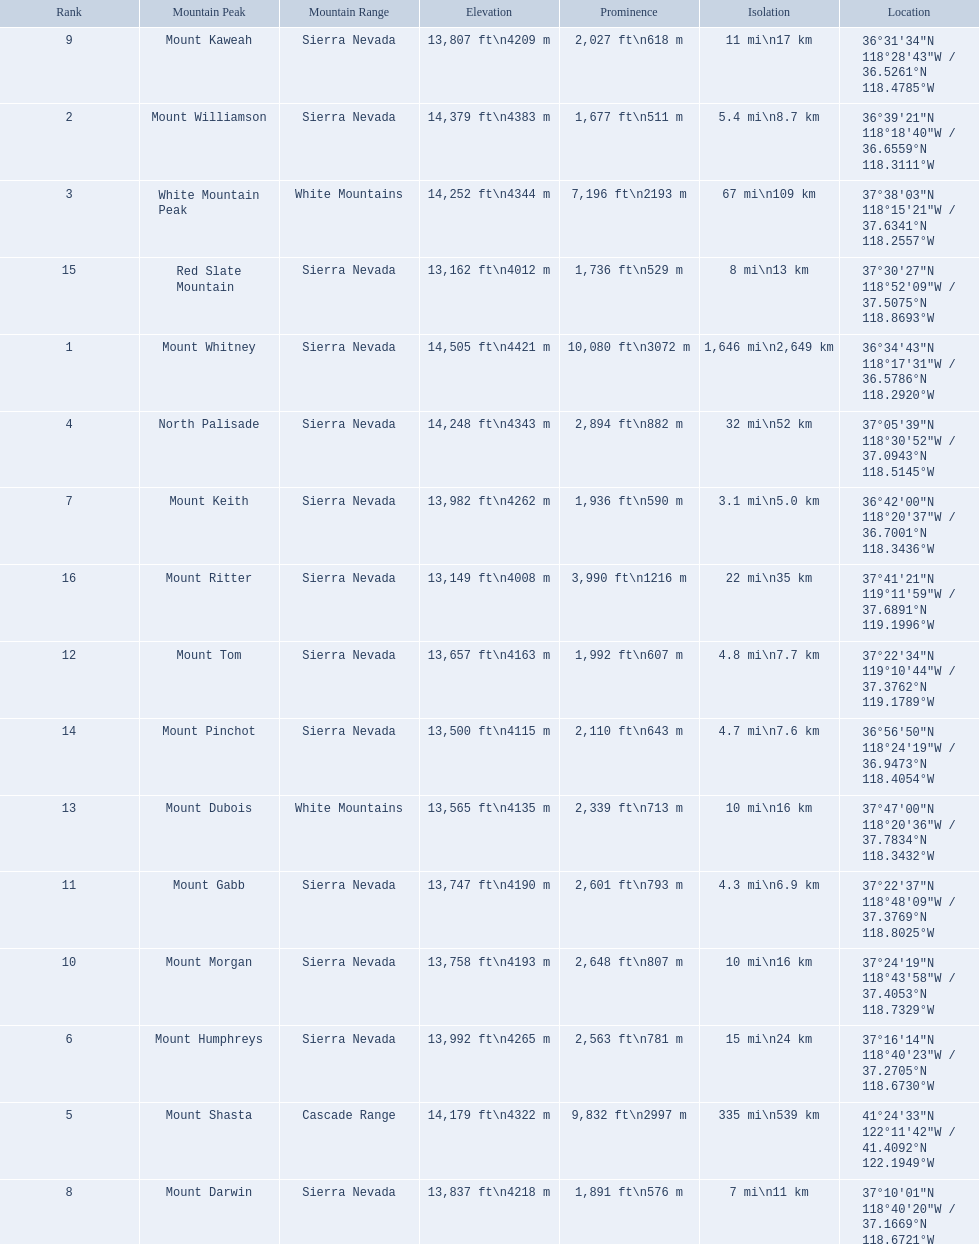What are the listed elevations? 14,505 ft\n4421 m, 14,379 ft\n4383 m, 14,252 ft\n4344 m, 14,248 ft\n4343 m, 14,179 ft\n4322 m, 13,992 ft\n4265 m, 13,982 ft\n4262 m, 13,837 ft\n4218 m, 13,807 ft\n4209 m, 13,758 ft\n4193 m, 13,747 ft\n4190 m, 13,657 ft\n4163 m, 13,565 ft\n4135 m, 13,500 ft\n4115 m, 13,162 ft\n4012 m, 13,149 ft\n4008 m. Which of those is 13,149 ft or below? 13,149 ft\n4008 m. To what mountain peak does that value correspond? Mount Ritter. 